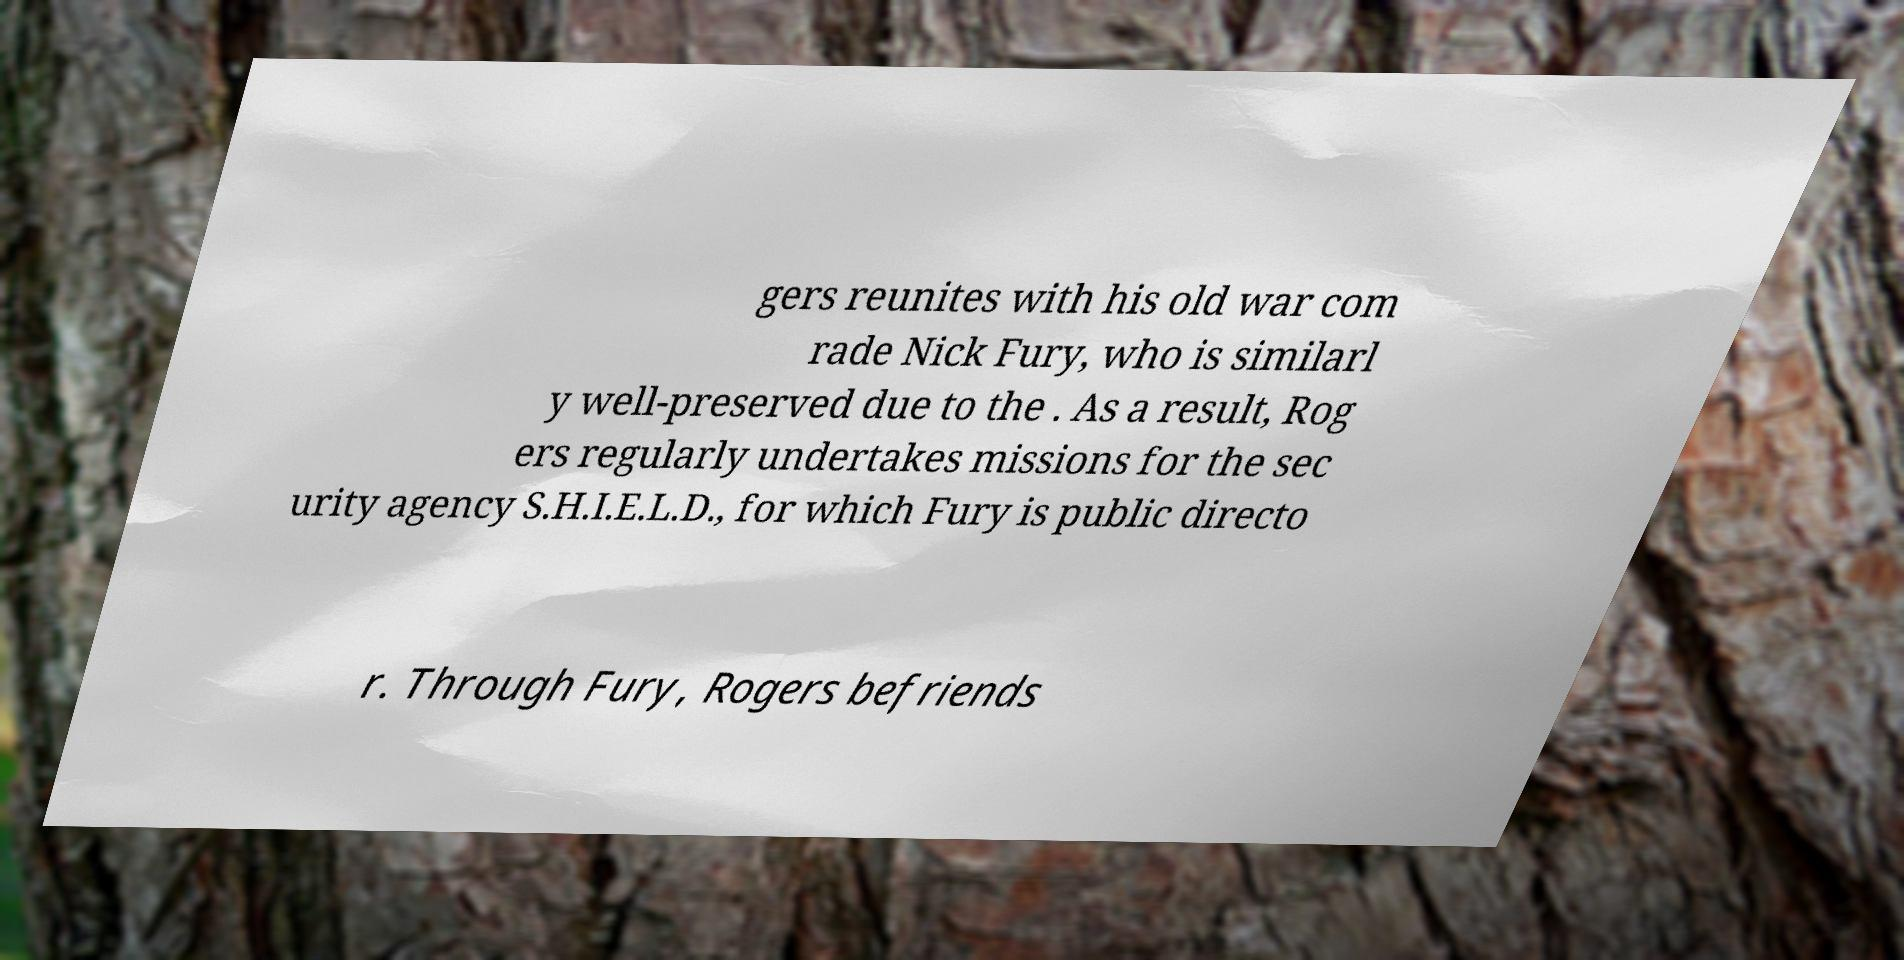Could you assist in decoding the text presented in this image and type it out clearly? gers reunites with his old war com rade Nick Fury, who is similarl y well-preserved due to the . As a result, Rog ers regularly undertakes missions for the sec urity agency S.H.I.E.L.D., for which Fury is public directo r. Through Fury, Rogers befriends 